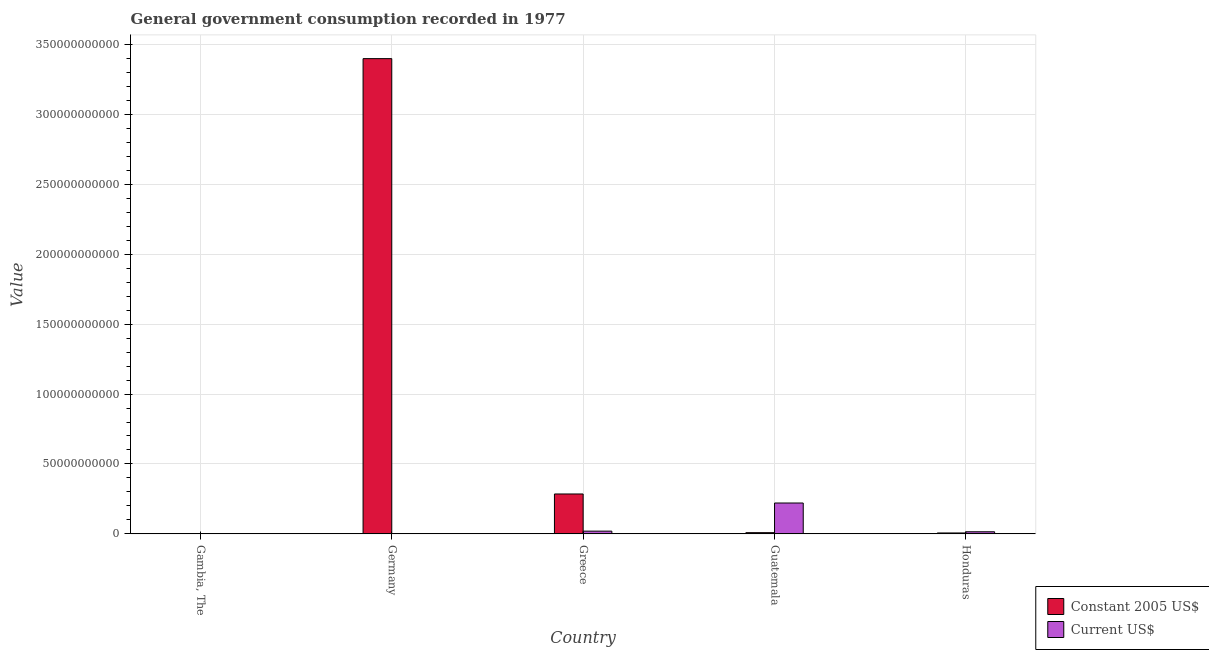In how many cases, is the number of bars for a given country not equal to the number of legend labels?
Keep it short and to the point. 0. What is the value consumed in constant 2005 us$ in Germany?
Offer a terse response. 3.40e+11. Across all countries, what is the maximum value consumed in constant 2005 us$?
Make the answer very short. 3.40e+11. Across all countries, what is the minimum value consumed in current us$?
Your answer should be compact. 6.27e+07. In which country was the value consumed in current us$ maximum?
Your answer should be compact. Guatemala. In which country was the value consumed in constant 2005 us$ minimum?
Your response must be concise. Gambia, The. What is the total value consumed in current us$ in the graph?
Your answer should be very brief. 2.57e+1. What is the difference between the value consumed in constant 2005 us$ in Greece and that in Guatemala?
Your response must be concise. 2.77e+1. What is the difference between the value consumed in constant 2005 us$ in Honduras and the value consumed in current us$ in Guatemala?
Offer a terse response. -2.14e+1. What is the average value consumed in current us$ per country?
Offer a very short reply. 5.15e+09. What is the difference between the value consumed in current us$ and value consumed in constant 2005 us$ in Guatemala?
Ensure brevity in your answer.  2.12e+1. What is the ratio of the value consumed in current us$ in Gambia, The to that in Honduras?
Keep it short and to the point. 0.04. Is the value consumed in constant 2005 us$ in Gambia, The less than that in Greece?
Provide a succinct answer. Yes. Is the difference between the value consumed in constant 2005 us$ in Germany and Honduras greater than the difference between the value consumed in current us$ in Germany and Honduras?
Your response must be concise. Yes. What is the difference between the highest and the second highest value consumed in constant 2005 us$?
Offer a very short reply. 3.11e+11. What is the difference between the highest and the lowest value consumed in current us$?
Offer a very short reply. 2.20e+1. What does the 1st bar from the left in Gambia, The represents?
Offer a terse response. Constant 2005 US$. What does the 1st bar from the right in Gambia, The represents?
Your response must be concise. Current US$. How many bars are there?
Offer a very short reply. 10. What is the difference between two consecutive major ticks on the Y-axis?
Ensure brevity in your answer.  5.00e+1. How are the legend labels stacked?
Provide a short and direct response. Vertical. What is the title of the graph?
Your answer should be very brief. General government consumption recorded in 1977. Does "Grants" appear as one of the legend labels in the graph?
Keep it short and to the point. No. What is the label or title of the Y-axis?
Provide a succinct answer. Value. What is the Value of Constant 2005 US$ in Gambia, The?
Your answer should be compact. 1.80e+07. What is the Value in Current US$ in Gambia, The?
Offer a terse response. 6.27e+07. What is the Value of Constant 2005 US$ in Germany?
Provide a short and direct response. 3.40e+11. What is the Value of Current US$ in Germany?
Your response must be concise. 1.58e+08. What is the Value in Constant 2005 US$ in Greece?
Offer a very short reply. 2.85e+1. What is the Value of Current US$ in Greece?
Your response must be concise. 1.95e+09. What is the Value in Constant 2005 US$ in Guatemala?
Ensure brevity in your answer.  8.62e+08. What is the Value in Current US$ in Guatemala?
Offer a very short reply. 2.21e+1. What is the Value of Constant 2005 US$ in Honduras?
Offer a very short reply. 6.40e+08. What is the Value of Current US$ in Honduras?
Ensure brevity in your answer.  1.50e+09. Across all countries, what is the maximum Value of Constant 2005 US$?
Give a very brief answer. 3.40e+11. Across all countries, what is the maximum Value of Current US$?
Keep it short and to the point. 2.21e+1. Across all countries, what is the minimum Value in Constant 2005 US$?
Offer a terse response. 1.80e+07. Across all countries, what is the minimum Value of Current US$?
Provide a succinct answer. 6.27e+07. What is the total Value of Constant 2005 US$ in the graph?
Provide a succinct answer. 3.70e+11. What is the total Value in Current US$ in the graph?
Your answer should be very brief. 2.57e+1. What is the difference between the Value in Constant 2005 US$ in Gambia, The and that in Germany?
Make the answer very short. -3.40e+11. What is the difference between the Value of Current US$ in Gambia, The and that in Germany?
Keep it short and to the point. -9.54e+07. What is the difference between the Value of Constant 2005 US$ in Gambia, The and that in Greece?
Make the answer very short. -2.85e+1. What is the difference between the Value in Current US$ in Gambia, The and that in Greece?
Make the answer very short. -1.88e+09. What is the difference between the Value of Constant 2005 US$ in Gambia, The and that in Guatemala?
Your answer should be compact. -8.44e+08. What is the difference between the Value of Current US$ in Gambia, The and that in Guatemala?
Keep it short and to the point. -2.20e+1. What is the difference between the Value in Constant 2005 US$ in Gambia, The and that in Honduras?
Provide a short and direct response. -6.22e+08. What is the difference between the Value of Current US$ in Gambia, The and that in Honduras?
Your response must be concise. -1.43e+09. What is the difference between the Value in Constant 2005 US$ in Germany and that in Greece?
Offer a terse response. 3.11e+11. What is the difference between the Value in Current US$ in Germany and that in Greece?
Keep it short and to the point. -1.79e+09. What is the difference between the Value of Constant 2005 US$ in Germany and that in Guatemala?
Provide a succinct answer. 3.39e+11. What is the difference between the Value in Current US$ in Germany and that in Guatemala?
Give a very brief answer. -2.19e+1. What is the difference between the Value in Constant 2005 US$ in Germany and that in Honduras?
Keep it short and to the point. 3.39e+11. What is the difference between the Value in Current US$ in Germany and that in Honduras?
Your response must be concise. -1.34e+09. What is the difference between the Value of Constant 2005 US$ in Greece and that in Guatemala?
Ensure brevity in your answer.  2.77e+1. What is the difference between the Value in Current US$ in Greece and that in Guatemala?
Keep it short and to the point. -2.01e+1. What is the difference between the Value of Constant 2005 US$ in Greece and that in Honduras?
Give a very brief answer. 2.79e+1. What is the difference between the Value in Current US$ in Greece and that in Honduras?
Your answer should be very brief. 4.51e+08. What is the difference between the Value in Constant 2005 US$ in Guatemala and that in Honduras?
Offer a terse response. 2.22e+08. What is the difference between the Value in Current US$ in Guatemala and that in Honduras?
Your answer should be very brief. 2.06e+1. What is the difference between the Value in Constant 2005 US$ in Gambia, The and the Value in Current US$ in Germany?
Keep it short and to the point. -1.40e+08. What is the difference between the Value of Constant 2005 US$ in Gambia, The and the Value of Current US$ in Greece?
Make the answer very short. -1.93e+09. What is the difference between the Value of Constant 2005 US$ in Gambia, The and the Value of Current US$ in Guatemala?
Offer a terse response. -2.21e+1. What is the difference between the Value in Constant 2005 US$ in Gambia, The and the Value in Current US$ in Honduras?
Your answer should be compact. -1.48e+09. What is the difference between the Value in Constant 2005 US$ in Germany and the Value in Current US$ in Greece?
Make the answer very short. 3.38e+11. What is the difference between the Value of Constant 2005 US$ in Germany and the Value of Current US$ in Guatemala?
Make the answer very short. 3.18e+11. What is the difference between the Value of Constant 2005 US$ in Germany and the Value of Current US$ in Honduras?
Provide a short and direct response. 3.38e+11. What is the difference between the Value in Constant 2005 US$ in Greece and the Value in Current US$ in Guatemala?
Give a very brief answer. 6.46e+09. What is the difference between the Value in Constant 2005 US$ in Greece and the Value in Current US$ in Honduras?
Make the answer very short. 2.70e+1. What is the difference between the Value in Constant 2005 US$ in Guatemala and the Value in Current US$ in Honduras?
Make the answer very short. -6.34e+08. What is the average Value in Constant 2005 US$ per country?
Ensure brevity in your answer.  7.40e+1. What is the average Value in Current US$ per country?
Your answer should be very brief. 5.15e+09. What is the difference between the Value of Constant 2005 US$ and Value of Current US$ in Gambia, The?
Your answer should be compact. -4.47e+07. What is the difference between the Value of Constant 2005 US$ and Value of Current US$ in Germany?
Keep it short and to the point. 3.40e+11. What is the difference between the Value in Constant 2005 US$ and Value in Current US$ in Greece?
Your answer should be very brief. 2.66e+1. What is the difference between the Value in Constant 2005 US$ and Value in Current US$ in Guatemala?
Keep it short and to the point. -2.12e+1. What is the difference between the Value of Constant 2005 US$ and Value of Current US$ in Honduras?
Your response must be concise. -8.55e+08. What is the ratio of the Value in Constant 2005 US$ in Gambia, The to that in Germany?
Your answer should be compact. 0. What is the ratio of the Value of Current US$ in Gambia, The to that in Germany?
Make the answer very short. 0.4. What is the ratio of the Value in Constant 2005 US$ in Gambia, The to that in Greece?
Your response must be concise. 0. What is the ratio of the Value of Current US$ in Gambia, The to that in Greece?
Ensure brevity in your answer.  0.03. What is the ratio of the Value in Constant 2005 US$ in Gambia, The to that in Guatemala?
Keep it short and to the point. 0.02. What is the ratio of the Value of Current US$ in Gambia, The to that in Guatemala?
Your response must be concise. 0. What is the ratio of the Value in Constant 2005 US$ in Gambia, The to that in Honduras?
Give a very brief answer. 0.03. What is the ratio of the Value in Current US$ in Gambia, The to that in Honduras?
Provide a short and direct response. 0.04. What is the ratio of the Value in Constant 2005 US$ in Germany to that in Greece?
Your response must be concise. 11.92. What is the ratio of the Value of Current US$ in Germany to that in Greece?
Make the answer very short. 0.08. What is the ratio of the Value in Constant 2005 US$ in Germany to that in Guatemala?
Offer a terse response. 394.35. What is the ratio of the Value of Current US$ in Germany to that in Guatemala?
Ensure brevity in your answer.  0.01. What is the ratio of the Value in Constant 2005 US$ in Germany to that in Honduras?
Give a very brief answer. 530.96. What is the ratio of the Value of Current US$ in Germany to that in Honduras?
Offer a terse response. 0.11. What is the ratio of the Value in Constant 2005 US$ in Greece to that in Guatemala?
Keep it short and to the point. 33.09. What is the ratio of the Value of Current US$ in Greece to that in Guatemala?
Ensure brevity in your answer.  0.09. What is the ratio of the Value in Constant 2005 US$ in Greece to that in Honduras?
Make the answer very short. 44.56. What is the ratio of the Value of Current US$ in Greece to that in Honduras?
Keep it short and to the point. 1.3. What is the ratio of the Value in Constant 2005 US$ in Guatemala to that in Honduras?
Ensure brevity in your answer.  1.35. What is the ratio of the Value in Current US$ in Guatemala to that in Honduras?
Ensure brevity in your answer.  14.76. What is the difference between the highest and the second highest Value in Constant 2005 US$?
Your answer should be compact. 3.11e+11. What is the difference between the highest and the second highest Value in Current US$?
Provide a short and direct response. 2.01e+1. What is the difference between the highest and the lowest Value of Constant 2005 US$?
Your response must be concise. 3.40e+11. What is the difference between the highest and the lowest Value of Current US$?
Give a very brief answer. 2.20e+1. 